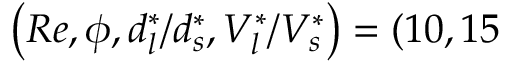<formula> <loc_0><loc_0><loc_500><loc_500>\left ( R e , \phi , d _ { l } ^ { * } / d _ { s } ^ { * } , V _ { l } ^ { * } / V _ { s } ^ { * } \right ) = ( 1 0 , 1 5 \</formula> 